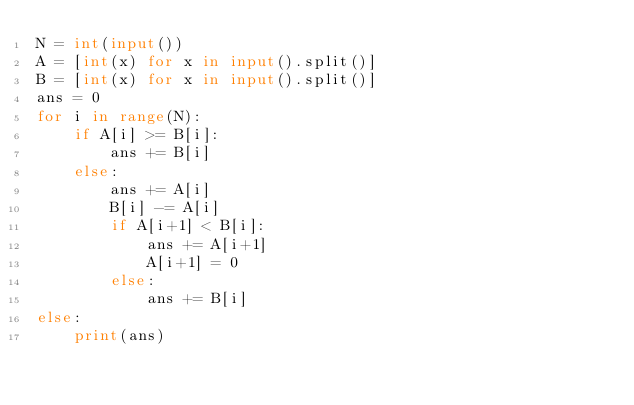Convert code to text. <code><loc_0><loc_0><loc_500><loc_500><_Python_>N = int(input())
A = [int(x) for x in input().split()]
B = [int(x) for x in input().split()]
ans = 0
for i in range(N):
    if A[i] >= B[i]:
        ans += B[i]
    else:
        ans += A[i]
        B[i] -= A[i]
        if A[i+1] < B[i]:
            ans += A[i+1]
            A[i+1] = 0
        else:
            ans += B[i]
else:
    print(ans)
</code> 